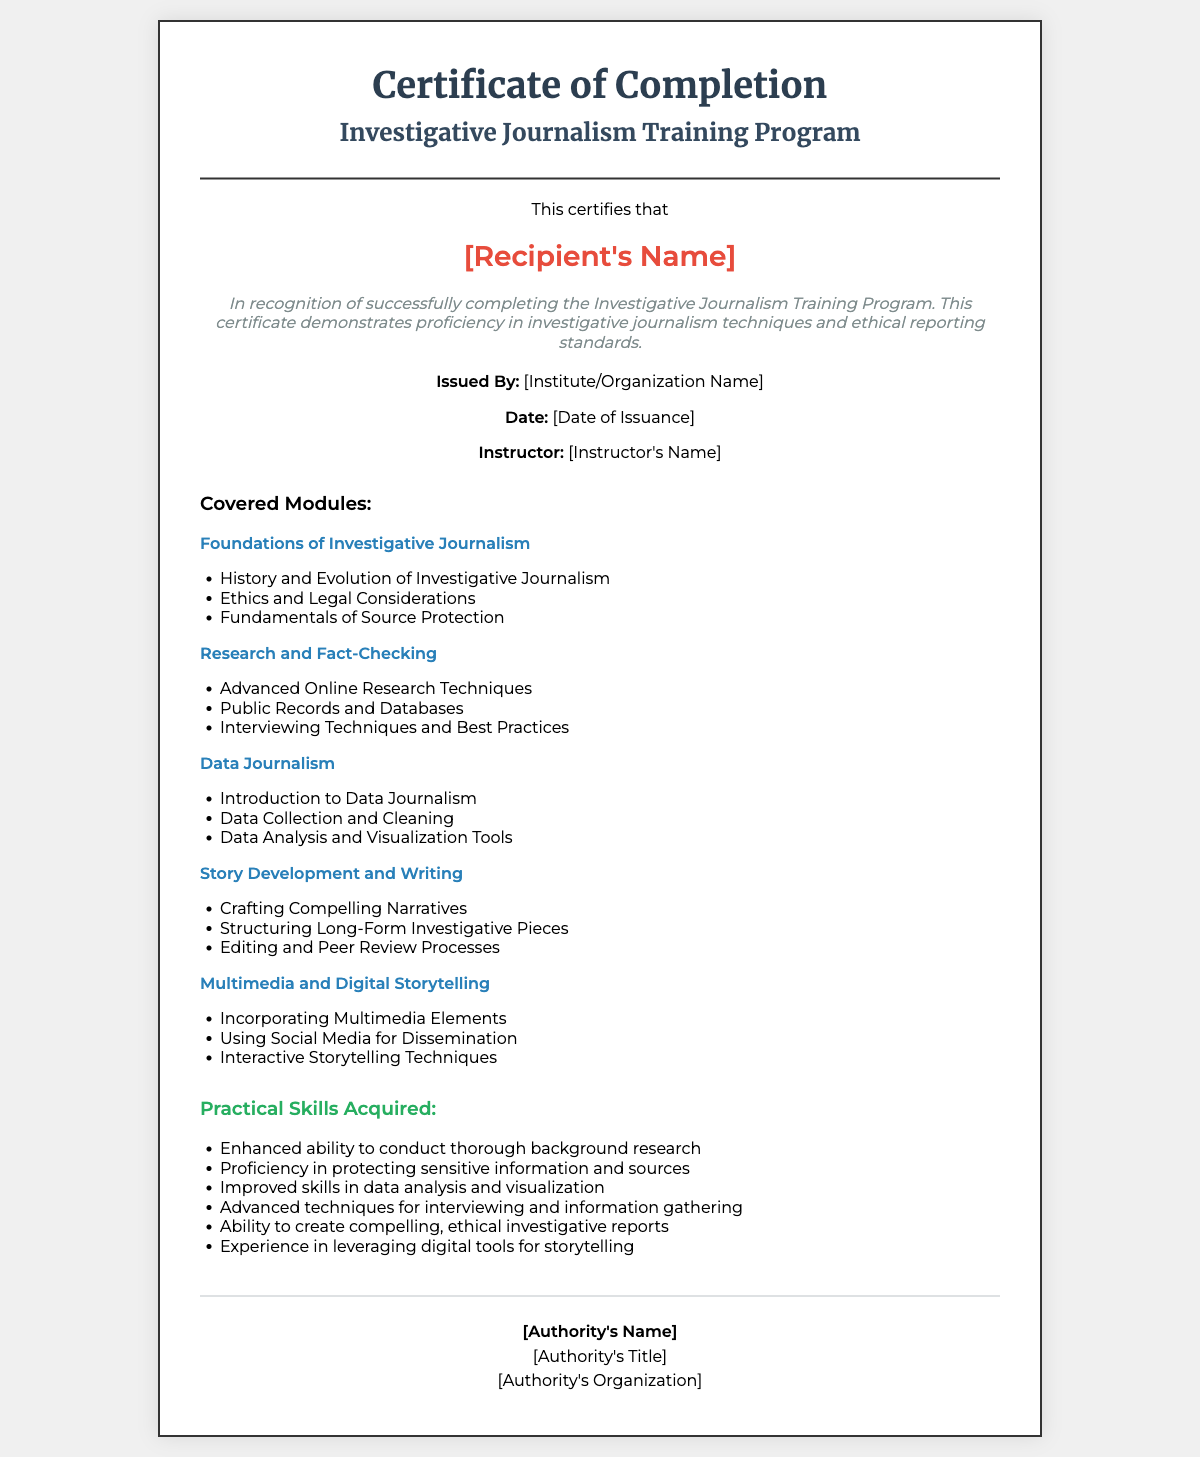What is the title of the training program? The title is mentioned in the header of the document as "Investigative Journalism Training Program."
Answer: Investigative Journalism Training Program Who is the recipient of the certificate? The recipient's name is indicated in the document as "[Recipient's Name]."
Answer: [Recipient's Name] What is one of the practical skills acquired through the training? The skills are listed under "Practical Skills Acquired," with one example being "Enhanced ability to conduct thorough background research."
Answer: Enhanced ability to conduct thorough background research When was the certificate issued? The date of issuance is noted in the document as "[Date of Issuance]."
Answer: [Date of Issuance] What is the name of the instructor? The instructor's name is shown as "[Instructor's Name]" in the document.
Answer: [Instructor's Name] Which module covers interviewing techniques? The module covering this is "Research and Fact-Checking," which includes "Interviewing Techniques and Best Practices."
Answer: Research and Fact-Checking What is one ethical consideration mentioned in the training? The module titled "Foundations of Investigative Journalism" includes "Ethics and Legal Considerations."
Answer: Ethics and Legal Considerations Who issued the certificate? The issuer is stated as "[Institute/Organization Name]."
Answer: [Institute/Organization Name] What is an advanced technique taught in the training program? The document lists "Advanced techniques for interviewing and information gathering" as a skill gained.
Answer: Advanced techniques for interviewing and information gathering 